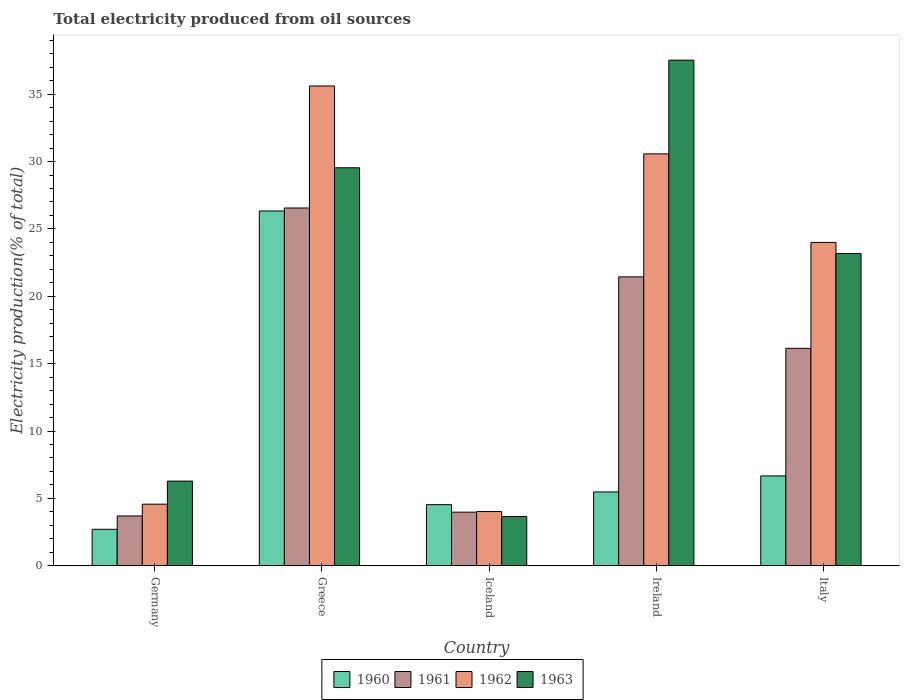How many different coloured bars are there?
Offer a very short reply. 4. How many groups of bars are there?
Keep it short and to the point. 5. How many bars are there on the 5th tick from the left?
Make the answer very short. 4. What is the label of the 1st group of bars from the left?
Ensure brevity in your answer.  Germany. In how many cases, is the number of bars for a given country not equal to the number of legend labels?
Ensure brevity in your answer.  0. What is the total electricity produced in 1961 in Ireland?
Provide a succinct answer. 21.44. Across all countries, what is the maximum total electricity produced in 1963?
Your response must be concise. 37.53. Across all countries, what is the minimum total electricity produced in 1962?
Provide a succinct answer. 4.03. In which country was the total electricity produced in 1963 maximum?
Make the answer very short. Ireland. In which country was the total electricity produced in 1962 minimum?
Your answer should be very brief. Iceland. What is the total total electricity produced in 1960 in the graph?
Your answer should be very brief. 45.73. What is the difference between the total electricity produced in 1960 in Ireland and that in Italy?
Make the answer very short. -1.19. What is the difference between the total electricity produced in 1961 in Greece and the total electricity produced in 1960 in Iceland?
Provide a succinct answer. 22.02. What is the average total electricity produced in 1962 per country?
Ensure brevity in your answer.  19.76. What is the difference between the total electricity produced of/in 1961 and total electricity produced of/in 1962 in Italy?
Provide a succinct answer. -7.86. In how many countries, is the total electricity produced in 1961 greater than 26 %?
Ensure brevity in your answer.  1. What is the ratio of the total electricity produced in 1963 in Iceland to that in Ireland?
Your response must be concise. 0.1. Is the total electricity produced in 1963 in Ireland less than that in Italy?
Your answer should be very brief. No. Is the difference between the total electricity produced in 1961 in Greece and Iceland greater than the difference between the total electricity produced in 1962 in Greece and Iceland?
Provide a succinct answer. No. What is the difference between the highest and the second highest total electricity produced in 1963?
Your answer should be compact. -7.99. What is the difference between the highest and the lowest total electricity produced in 1960?
Make the answer very short. 23.62. What does the 2nd bar from the left in Iceland represents?
Ensure brevity in your answer.  1961. How many countries are there in the graph?
Ensure brevity in your answer.  5. What is the difference between two consecutive major ticks on the Y-axis?
Your answer should be very brief. 5. Are the values on the major ticks of Y-axis written in scientific E-notation?
Your answer should be compact. No. Does the graph contain any zero values?
Your answer should be compact. No. Where does the legend appear in the graph?
Make the answer very short. Bottom center. How many legend labels are there?
Provide a short and direct response. 4. How are the legend labels stacked?
Give a very brief answer. Horizontal. What is the title of the graph?
Give a very brief answer. Total electricity produced from oil sources. What is the label or title of the Y-axis?
Provide a succinct answer. Electricity production(% of total). What is the Electricity production(% of total) of 1960 in Germany?
Your answer should be compact. 2.71. What is the Electricity production(% of total) in 1961 in Germany?
Your answer should be compact. 3.7. What is the Electricity production(% of total) of 1962 in Germany?
Offer a terse response. 4.57. What is the Electricity production(% of total) in 1963 in Germany?
Ensure brevity in your answer.  6.28. What is the Electricity production(% of total) in 1960 in Greece?
Offer a very short reply. 26.33. What is the Electricity production(% of total) in 1961 in Greece?
Offer a terse response. 26.55. What is the Electricity production(% of total) in 1962 in Greece?
Your response must be concise. 35.61. What is the Electricity production(% of total) in 1963 in Greece?
Make the answer very short. 29.54. What is the Electricity production(% of total) of 1960 in Iceland?
Provide a succinct answer. 4.54. What is the Electricity production(% of total) in 1961 in Iceland?
Give a very brief answer. 3.98. What is the Electricity production(% of total) in 1962 in Iceland?
Offer a very short reply. 4.03. What is the Electricity production(% of total) in 1963 in Iceland?
Ensure brevity in your answer.  3.66. What is the Electricity production(% of total) in 1960 in Ireland?
Make the answer very short. 5.48. What is the Electricity production(% of total) of 1961 in Ireland?
Offer a terse response. 21.44. What is the Electricity production(% of total) in 1962 in Ireland?
Your answer should be very brief. 30.57. What is the Electricity production(% of total) in 1963 in Ireland?
Ensure brevity in your answer.  37.53. What is the Electricity production(% of total) of 1960 in Italy?
Your response must be concise. 6.67. What is the Electricity production(% of total) in 1961 in Italy?
Your answer should be very brief. 16.14. What is the Electricity production(% of total) of 1962 in Italy?
Provide a short and direct response. 24. What is the Electricity production(% of total) of 1963 in Italy?
Your response must be concise. 23.17. Across all countries, what is the maximum Electricity production(% of total) of 1960?
Offer a terse response. 26.33. Across all countries, what is the maximum Electricity production(% of total) of 1961?
Your response must be concise. 26.55. Across all countries, what is the maximum Electricity production(% of total) in 1962?
Provide a short and direct response. 35.61. Across all countries, what is the maximum Electricity production(% of total) in 1963?
Provide a short and direct response. 37.53. Across all countries, what is the minimum Electricity production(% of total) in 1960?
Offer a terse response. 2.71. Across all countries, what is the minimum Electricity production(% of total) of 1961?
Make the answer very short. 3.7. Across all countries, what is the minimum Electricity production(% of total) in 1962?
Keep it short and to the point. 4.03. Across all countries, what is the minimum Electricity production(% of total) in 1963?
Keep it short and to the point. 3.66. What is the total Electricity production(% of total) in 1960 in the graph?
Keep it short and to the point. 45.73. What is the total Electricity production(% of total) in 1961 in the graph?
Give a very brief answer. 71.81. What is the total Electricity production(% of total) of 1962 in the graph?
Give a very brief answer. 98.78. What is the total Electricity production(% of total) in 1963 in the graph?
Provide a short and direct response. 100.18. What is the difference between the Electricity production(% of total) of 1960 in Germany and that in Greece?
Your response must be concise. -23.62. What is the difference between the Electricity production(% of total) of 1961 in Germany and that in Greece?
Your answer should be compact. -22.86. What is the difference between the Electricity production(% of total) in 1962 in Germany and that in Greece?
Your response must be concise. -31.04. What is the difference between the Electricity production(% of total) in 1963 in Germany and that in Greece?
Offer a terse response. -23.26. What is the difference between the Electricity production(% of total) of 1960 in Germany and that in Iceland?
Make the answer very short. -1.83. What is the difference between the Electricity production(% of total) of 1961 in Germany and that in Iceland?
Offer a very short reply. -0.28. What is the difference between the Electricity production(% of total) of 1962 in Germany and that in Iceland?
Offer a terse response. 0.55. What is the difference between the Electricity production(% of total) of 1963 in Germany and that in Iceland?
Provide a succinct answer. 2.63. What is the difference between the Electricity production(% of total) of 1960 in Germany and that in Ireland?
Provide a succinct answer. -2.77. What is the difference between the Electricity production(% of total) of 1961 in Germany and that in Ireland?
Give a very brief answer. -17.75. What is the difference between the Electricity production(% of total) of 1962 in Germany and that in Ireland?
Your answer should be compact. -26. What is the difference between the Electricity production(% of total) in 1963 in Germany and that in Ireland?
Offer a terse response. -31.24. What is the difference between the Electricity production(% of total) of 1960 in Germany and that in Italy?
Provide a succinct answer. -3.96. What is the difference between the Electricity production(% of total) of 1961 in Germany and that in Italy?
Your answer should be compact. -12.44. What is the difference between the Electricity production(% of total) of 1962 in Germany and that in Italy?
Your response must be concise. -19.43. What is the difference between the Electricity production(% of total) in 1963 in Germany and that in Italy?
Provide a succinct answer. -16.89. What is the difference between the Electricity production(% of total) of 1960 in Greece and that in Iceland?
Provide a short and direct response. 21.79. What is the difference between the Electricity production(% of total) in 1961 in Greece and that in Iceland?
Give a very brief answer. 22.57. What is the difference between the Electricity production(% of total) in 1962 in Greece and that in Iceland?
Provide a short and direct response. 31.58. What is the difference between the Electricity production(% of total) in 1963 in Greece and that in Iceland?
Give a very brief answer. 25.88. What is the difference between the Electricity production(% of total) of 1960 in Greece and that in Ireland?
Provide a succinct answer. 20.85. What is the difference between the Electricity production(% of total) of 1961 in Greece and that in Ireland?
Offer a very short reply. 5.11. What is the difference between the Electricity production(% of total) in 1962 in Greece and that in Ireland?
Your answer should be compact. 5.04. What is the difference between the Electricity production(% of total) in 1963 in Greece and that in Ireland?
Make the answer very short. -7.99. What is the difference between the Electricity production(% of total) in 1960 in Greece and that in Italy?
Your answer should be compact. 19.66. What is the difference between the Electricity production(% of total) of 1961 in Greece and that in Italy?
Make the answer very short. 10.42. What is the difference between the Electricity production(% of total) in 1962 in Greece and that in Italy?
Offer a very short reply. 11.61. What is the difference between the Electricity production(% of total) of 1963 in Greece and that in Italy?
Your answer should be very brief. 6.37. What is the difference between the Electricity production(% of total) in 1960 in Iceland and that in Ireland?
Give a very brief answer. -0.94. What is the difference between the Electricity production(% of total) of 1961 in Iceland and that in Ireland?
Make the answer very short. -17.46. What is the difference between the Electricity production(% of total) in 1962 in Iceland and that in Ireland?
Provide a short and direct response. -26.55. What is the difference between the Electricity production(% of total) in 1963 in Iceland and that in Ireland?
Provide a short and direct response. -33.87. What is the difference between the Electricity production(% of total) in 1960 in Iceland and that in Italy?
Make the answer very short. -2.13. What is the difference between the Electricity production(% of total) in 1961 in Iceland and that in Italy?
Your response must be concise. -12.16. What is the difference between the Electricity production(% of total) of 1962 in Iceland and that in Italy?
Your answer should be compact. -19.97. What is the difference between the Electricity production(% of total) of 1963 in Iceland and that in Italy?
Provide a succinct answer. -19.52. What is the difference between the Electricity production(% of total) in 1960 in Ireland and that in Italy?
Keep it short and to the point. -1.19. What is the difference between the Electricity production(% of total) of 1961 in Ireland and that in Italy?
Offer a terse response. 5.3. What is the difference between the Electricity production(% of total) of 1962 in Ireland and that in Italy?
Your answer should be compact. 6.57. What is the difference between the Electricity production(% of total) in 1963 in Ireland and that in Italy?
Offer a terse response. 14.35. What is the difference between the Electricity production(% of total) of 1960 in Germany and the Electricity production(% of total) of 1961 in Greece?
Give a very brief answer. -23.85. What is the difference between the Electricity production(% of total) in 1960 in Germany and the Electricity production(% of total) in 1962 in Greece?
Give a very brief answer. -32.9. What is the difference between the Electricity production(% of total) of 1960 in Germany and the Electricity production(% of total) of 1963 in Greece?
Your answer should be compact. -26.83. What is the difference between the Electricity production(% of total) of 1961 in Germany and the Electricity production(% of total) of 1962 in Greece?
Offer a very short reply. -31.91. What is the difference between the Electricity production(% of total) of 1961 in Germany and the Electricity production(% of total) of 1963 in Greece?
Ensure brevity in your answer.  -25.84. What is the difference between the Electricity production(% of total) of 1962 in Germany and the Electricity production(% of total) of 1963 in Greece?
Make the answer very short. -24.97. What is the difference between the Electricity production(% of total) of 1960 in Germany and the Electricity production(% of total) of 1961 in Iceland?
Ensure brevity in your answer.  -1.27. What is the difference between the Electricity production(% of total) in 1960 in Germany and the Electricity production(% of total) in 1962 in Iceland?
Make the answer very short. -1.32. What is the difference between the Electricity production(% of total) in 1960 in Germany and the Electricity production(% of total) in 1963 in Iceland?
Your answer should be compact. -0.95. What is the difference between the Electricity production(% of total) in 1961 in Germany and the Electricity production(% of total) in 1962 in Iceland?
Provide a succinct answer. -0.33. What is the difference between the Electricity production(% of total) in 1961 in Germany and the Electricity production(% of total) in 1963 in Iceland?
Your answer should be compact. 0.04. What is the difference between the Electricity production(% of total) of 1962 in Germany and the Electricity production(% of total) of 1963 in Iceland?
Offer a very short reply. 0.91. What is the difference between the Electricity production(% of total) in 1960 in Germany and the Electricity production(% of total) in 1961 in Ireland?
Offer a very short reply. -18.73. What is the difference between the Electricity production(% of total) in 1960 in Germany and the Electricity production(% of total) in 1962 in Ireland?
Your answer should be very brief. -27.86. What is the difference between the Electricity production(% of total) of 1960 in Germany and the Electricity production(% of total) of 1963 in Ireland?
Your answer should be very brief. -34.82. What is the difference between the Electricity production(% of total) in 1961 in Germany and the Electricity production(% of total) in 1962 in Ireland?
Keep it short and to the point. -26.87. What is the difference between the Electricity production(% of total) in 1961 in Germany and the Electricity production(% of total) in 1963 in Ireland?
Provide a succinct answer. -33.83. What is the difference between the Electricity production(% of total) of 1962 in Germany and the Electricity production(% of total) of 1963 in Ireland?
Offer a very short reply. -32.95. What is the difference between the Electricity production(% of total) of 1960 in Germany and the Electricity production(% of total) of 1961 in Italy?
Ensure brevity in your answer.  -13.43. What is the difference between the Electricity production(% of total) in 1960 in Germany and the Electricity production(% of total) in 1962 in Italy?
Keep it short and to the point. -21.29. What is the difference between the Electricity production(% of total) in 1960 in Germany and the Electricity production(% of total) in 1963 in Italy?
Offer a very short reply. -20.47. What is the difference between the Electricity production(% of total) in 1961 in Germany and the Electricity production(% of total) in 1962 in Italy?
Ensure brevity in your answer.  -20.3. What is the difference between the Electricity production(% of total) in 1961 in Germany and the Electricity production(% of total) in 1963 in Italy?
Make the answer very short. -19.48. What is the difference between the Electricity production(% of total) of 1962 in Germany and the Electricity production(% of total) of 1963 in Italy?
Your answer should be compact. -18.6. What is the difference between the Electricity production(% of total) of 1960 in Greece and the Electricity production(% of total) of 1961 in Iceland?
Ensure brevity in your answer.  22.35. What is the difference between the Electricity production(% of total) of 1960 in Greece and the Electricity production(% of total) of 1962 in Iceland?
Your answer should be compact. 22.31. What is the difference between the Electricity production(% of total) of 1960 in Greece and the Electricity production(% of total) of 1963 in Iceland?
Provide a succinct answer. 22.67. What is the difference between the Electricity production(% of total) of 1961 in Greece and the Electricity production(% of total) of 1962 in Iceland?
Offer a terse response. 22.53. What is the difference between the Electricity production(% of total) of 1961 in Greece and the Electricity production(% of total) of 1963 in Iceland?
Provide a short and direct response. 22.9. What is the difference between the Electricity production(% of total) in 1962 in Greece and the Electricity production(% of total) in 1963 in Iceland?
Make the answer very short. 31.95. What is the difference between the Electricity production(% of total) in 1960 in Greece and the Electricity production(% of total) in 1961 in Ireland?
Provide a short and direct response. 4.89. What is the difference between the Electricity production(% of total) in 1960 in Greece and the Electricity production(% of total) in 1962 in Ireland?
Keep it short and to the point. -4.24. What is the difference between the Electricity production(% of total) of 1960 in Greece and the Electricity production(% of total) of 1963 in Ireland?
Your answer should be compact. -11.19. What is the difference between the Electricity production(% of total) of 1961 in Greece and the Electricity production(% of total) of 1962 in Ireland?
Make the answer very short. -4.02. What is the difference between the Electricity production(% of total) of 1961 in Greece and the Electricity production(% of total) of 1963 in Ireland?
Your answer should be very brief. -10.97. What is the difference between the Electricity production(% of total) of 1962 in Greece and the Electricity production(% of total) of 1963 in Ireland?
Provide a succinct answer. -1.92. What is the difference between the Electricity production(% of total) in 1960 in Greece and the Electricity production(% of total) in 1961 in Italy?
Your response must be concise. 10.19. What is the difference between the Electricity production(% of total) of 1960 in Greece and the Electricity production(% of total) of 1962 in Italy?
Keep it short and to the point. 2.33. What is the difference between the Electricity production(% of total) in 1960 in Greece and the Electricity production(% of total) in 1963 in Italy?
Provide a succinct answer. 3.16. What is the difference between the Electricity production(% of total) of 1961 in Greece and the Electricity production(% of total) of 1962 in Italy?
Provide a succinct answer. 2.55. What is the difference between the Electricity production(% of total) in 1961 in Greece and the Electricity production(% of total) in 1963 in Italy?
Your answer should be compact. 3.38. What is the difference between the Electricity production(% of total) of 1962 in Greece and the Electricity production(% of total) of 1963 in Italy?
Give a very brief answer. 12.44. What is the difference between the Electricity production(% of total) in 1960 in Iceland and the Electricity production(% of total) in 1961 in Ireland?
Offer a very short reply. -16.91. What is the difference between the Electricity production(% of total) of 1960 in Iceland and the Electricity production(% of total) of 1962 in Ireland?
Your answer should be very brief. -26.03. What is the difference between the Electricity production(% of total) in 1960 in Iceland and the Electricity production(% of total) in 1963 in Ireland?
Your answer should be very brief. -32.99. What is the difference between the Electricity production(% of total) in 1961 in Iceland and the Electricity production(% of total) in 1962 in Ireland?
Keep it short and to the point. -26.59. What is the difference between the Electricity production(% of total) of 1961 in Iceland and the Electricity production(% of total) of 1963 in Ireland?
Provide a succinct answer. -33.55. What is the difference between the Electricity production(% of total) in 1962 in Iceland and the Electricity production(% of total) in 1963 in Ireland?
Keep it short and to the point. -33.5. What is the difference between the Electricity production(% of total) of 1960 in Iceland and the Electricity production(% of total) of 1961 in Italy?
Provide a short and direct response. -11.6. What is the difference between the Electricity production(% of total) in 1960 in Iceland and the Electricity production(% of total) in 1962 in Italy?
Make the answer very short. -19.46. What is the difference between the Electricity production(% of total) of 1960 in Iceland and the Electricity production(% of total) of 1963 in Italy?
Make the answer very short. -18.64. What is the difference between the Electricity production(% of total) of 1961 in Iceland and the Electricity production(% of total) of 1962 in Italy?
Your answer should be compact. -20.02. What is the difference between the Electricity production(% of total) of 1961 in Iceland and the Electricity production(% of total) of 1963 in Italy?
Your answer should be very brief. -19.19. What is the difference between the Electricity production(% of total) of 1962 in Iceland and the Electricity production(% of total) of 1963 in Italy?
Provide a succinct answer. -19.15. What is the difference between the Electricity production(% of total) of 1960 in Ireland and the Electricity production(% of total) of 1961 in Italy?
Make the answer very short. -10.66. What is the difference between the Electricity production(% of total) of 1960 in Ireland and the Electricity production(% of total) of 1962 in Italy?
Give a very brief answer. -18.52. What is the difference between the Electricity production(% of total) of 1960 in Ireland and the Electricity production(% of total) of 1963 in Italy?
Your response must be concise. -17.69. What is the difference between the Electricity production(% of total) of 1961 in Ireland and the Electricity production(% of total) of 1962 in Italy?
Your answer should be compact. -2.56. What is the difference between the Electricity production(% of total) of 1961 in Ireland and the Electricity production(% of total) of 1963 in Italy?
Keep it short and to the point. -1.73. What is the difference between the Electricity production(% of total) of 1962 in Ireland and the Electricity production(% of total) of 1963 in Italy?
Make the answer very short. 7.4. What is the average Electricity production(% of total) in 1960 per country?
Provide a succinct answer. 9.15. What is the average Electricity production(% of total) in 1961 per country?
Provide a short and direct response. 14.36. What is the average Electricity production(% of total) in 1962 per country?
Provide a succinct answer. 19.76. What is the average Electricity production(% of total) of 1963 per country?
Your answer should be compact. 20.04. What is the difference between the Electricity production(% of total) of 1960 and Electricity production(% of total) of 1961 in Germany?
Offer a terse response. -0.99. What is the difference between the Electricity production(% of total) of 1960 and Electricity production(% of total) of 1962 in Germany?
Keep it short and to the point. -1.86. What is the difference between the Electricity production(% of total) in 1960 and Electricity production(% of total) in 1963 in Germany?
Your answer should be very brief. -3.58. What is the difference between the Electricity production(% of total) in 1961 and Electricity production(% of total) in 1962 in Germany?
Your answer should be very brief. -0.87. What is the difference between the Electricity production(% of total) of 1961 and Electricity production(% of total) of 1963 in Germany?
Your answer should be compact. -2.59. What is the difference between the Electricity production(% of total) in 1962 and Electricity production(% of total) in 1963 in Germany?
Your answer should be very brief. -1.71. What is the difference between the Electricity production(% of total) in 1960 and Electricity production(% of total) in 1961 in Greece?
Give a very brief answer. -0.22. What is the difference between the Electricity production(% of total) of 1960 and Electricity production(% of total) of 1962 in Greece?
Offer a very short reply. -9.28. What is the difference between the Electricity production(% of total) in 1960 and Electricity production(% of total) in 1963 in Greece?
Keep it short and to the point. -3.21. What is the difference between the Electricity production(% of total) of 1961 and Electricity production(% of total) of 1962 in Greece?
Ensure brevity in your answer.  -9.06. What is the difference between the Electricity production(% of total) of 1961 and Electricity production(% of total) of 1963 in Greece?
Provide a short and direct response. -2.99. What is the difference between the Electricity production(% of total) in 1962 and Electricity production(% of total) in 1963 in Greece?
Offer a very short reply. 6.07. What is the difference between the Electricity production(% of total) in 1960 and Electricity production(% of total) in 1961 in Iceland?
Offer a terse response. 0.56. What is the difference between the Electricity production(% of total) of 1960 and Electricity production(% of total) of 1962 in Iceland?
Give a very brief answer. 0.51. What is the difference between the Electricity production(% of total) in 1960 and Electricity production(% of total) in 1963 in Iceland?
Your response must be concise. 0.88. What is the difference between the Electricity production(% of total) of 1961 and Electricity production(% of total) of 1962 in Iceland?
Provide a short and direct response. -0.05. What is the difference between the Electricity production(% of total) of 1961 and Electricity production(% of total) of 1963 in Iceland?
Ensure brevity in your answer.  0.32. What is the difference between the Electricity production(% of total) in 1962 and Electricity production(% of total) in 1963 in Iceland?
Ensure brevity in your answer.  0.37. What is the difference between the Electricity production(% of total) in 1960 and Electricity production(% of total) in 1961 in Ireland?
Provide a short and direct response. -15.96. What is the difference between the Electricity production(% of total) of 1960 and Electricity production(% of total) of 1962 in Ireland?
Keep it short and to the point. -25.09. What is the difference between the Electricity production(% of total) of 1960 and Electricity production(% of total) of 1963 in Ireland?
Make the answer very short. -32.04. What is the difference between the Electricity production(% of total) in 1961 and Electricity production(% of total) in 1962 in Ireland?
Offer a very short reply. -9.13. What is the difference between the Electricity production(% of total) in 1961 and Electricity production(% of total) in 1963 in Ireland?
Keep it short and to the point. -16.08. What is the difference between the Electricity production(% of total) of 1962 and Electricity production(% of total) of 1963 in Ireland?
Keep it short and to the point. -6.95. What is the difference between the Electricity production(% of total) in 1960 and Electricity production(% of total) in 1961 in Italy?
Your answer should be very brief. -9.47. What is the difference between the Electricity production(% of total) of 1960 and Electricity production(% of total) of 1962 in Italy?
Give a very brief answer. -17.33. What is the difference between the Electricity production(% of total) in 1960 and Electricity production(% of total) in 1963 in Italy?
Keep it short and to the point. -16.5. What is the difference between the Electricity production(% of total) of 1961 and Electricity production(% of total) of 1962 in Italy?
Offer a very short reply. -7.86. What is the difference between the Electricity production(% of total) of 1961 and Electricity production(% of total) of 1963 in Italy?
Provide a succinct answer. -7.04. What is the difference between the Electricity production(% of total) in 1962 and Electricity production(% of total) in 1963 in Italy?
Keep it short and to the point. 0.83. What is the ratio of the Electricity production(% of total) of 1960 in Germany to that in Greece?
Offer a very short reply. 0.1. What is the ratio of the Electricity production(% of total) of 1961 in Germany to that in Greece?
Keep it short and to the point. 0.14. What is the ratio of the Electricity production(% of total) of 1962 in Germany to that in Greece?
Offer a terse response. 0.13. What is the ratio of the Electricity production(% of total) in 1963 in Germany to that in Greece?
Offer a terse response. 0.21. What is the ratio of the Electricity production(% of total) in 1960 in Germany to that in Iceland?
Keep it short and to the point. 0.6. What is the ratio of the Electricity production(% of total) in 1961 in Germany to that in Iceland?
Keep it short and to the point. 0.93. What is the ratio of the Electricity production(% of total) of 1962 in Germany to that in Iceland?
Make the answer very short. 1.14. What is the ratio of the Electricity production(% of total) of 1963 in Germany to that in Iceland?
Ensure brevity in your answer.  1.72. What is the ratio of the Electricity production(% of total) in 1960 in Germany to that in Ireland?
Your answer should be very brief. 0.49. What is the ratio of the Electricity production(% of total) of 1961 in Germany to that in Ireland?
Your answer should be compact. 0.17. What is the ratio of the Electricity production(% of total) of 1962 in Germany to that in Ireland?
Your response must be concise. 0.15. What is the ratio of the Electricity production(% of total) of 1963 in Germany to that in Ireland?
Your response must be concise. 0.17. What is the ratio of the Electricity production(% of total) in 1960 in Germany to that in Italy?
Provide a succinct answer. 0.41. What is the ratio of the Electricity production(% of total) in 1961 in Germany to that in Italy?
Your answer should be compact. 0.23. What is the ratio of the Electricity production(% of total) in 1962 in Germany to that in Italy?
Your response must be concise. 0.19. What is the ratio of the Electricity production(% of total) of 1963 in Germany to that in Italy?
Your response must be concise. 0.27. What is the ratio of the Electricity production(% of total) of 1960 in Greece to that in Iceland?
Ensure brevity in your answer.  5.8. What is the ratio of the Electricity production(% of total) of 1961 in Greece to that in Iceland?
Provide a succinct answer. 6.67. What is the ratio of the Electricity production(% of total) of 1962 in Greece to that in Iceland?
Your answer should be compact. 8.85. What is the ratio of the Electricity production(% of total) in 1963 in Greece to that in Iceland?
Make the answer very short. 8.07. What is the ratio of the Electricity production(% of total) of 1960 in Greece to that in Ireland?
Offer a very short reply. 4.8. What is the ratio of the Electricity production(% of total) of 1961 in Greece to that in Ireland?
Provide a short and direct response. 1.24. What is the ratio of the Electricity production(% of total) in 1962 in Greece to that in Ireland?
Your response must be concise. 1.16. What is the ratio of the Electricity production(% of total) in 1963 in Greece to that in Ireland?
Make the answer very short. 0.79. What is the ratio of the Electricity production(% of total) in 1960 in Greece to that in Italy?
Your answer should be compact. 3.95. What is the ratio of the Electricity production(% of total) of 1961 in Greece to that in Italy?
Keep it short and to the point. 1.65. What is the ratio of the Electricity production(% of total) of 1962 in Greece to that in Italy?
Your answer should be compact. 1.48. What is the ratio of the Electricity production(% of total) in 1963 in Greece to that in Italy?
Provide a succinct answer. 1.27. What is the ratio of the Electricity production(% of total) in 1960 in Iceland to that in Ireland?
Keep it short and to the point. 0.83. What is the ratio of the Electricity production(% of total) of 1961 in Iceland to that in Ireland?
Offer a terse response. 0.19. What is the ratio of the Electricity production(% of total) of 1962 in Iceland to that in Ireland?
Provide a succinct answer. 0.13. What is the ratio of the Electricity production(% of total) of 1963 in Iceland to that in Ireland?
Make the answer very short. 0.1. What is the ratio of the Electricity production(% of total) of 1960 in Iceland to that in Italy?
Keep it short and to the point. 0.68. What is the ratio of the Electricity production(% of total) of 1961 in Iceland to that in Italy?
Offer a very short reply. 0.25. What is the ratio of the Electricity production(% of total) in 1962 in Iceland to that in Italy?
Provide a short and direct response. 0.17. What is the ratio of the Electricity production(% of total) of 1963 in Iceland to that in Italy?
Your answer should be very brief. 0.16. What is the ratio of the Electricity production(% of total) of 1960 in Ireland to that in Italy?
Make the answer very short. 0.82. What is the ratio of the Electricity production(% of total) of 1961 in Ireland to that in Italy?
Provide a short and direct response. 1.33. What is the ratio of the Electricity production(% of total) in 1962 in Ireland to that in Italy?
Keep it short and to the point. 1.27. What is the ratio of the Electricity production(% of total) of 1963 in Ireland to that in Italy?
Your response must be concise. 1.62. What is the difference between the highest and the second highest Electricity production(% of total) of 1960?
Ensure brevity in your answer.  19.66. What is the difference between the highest and the second highest Electricity production(% of total) in 1961?
Make the answer very short. 5.11. What is the difference between the highest and the second highest Electricity production(% of total) of 1962?
Make the answer very short. 5.04. What is the difference between the highest and the second highest Electricity production(% of total) in 1963?
Your answer should be very brief. 7.99. What is the difference between the highest and the lowest Electricity production(% of total) of 1960?
Offer a very short reply. 23.62. What is the difference between the highest and the lowest Electricity production(% of total) of 1961?
Your response must be concise. 22.86. What is the difference between the highest and the lowest Electricity production(% of total) of 1962?
Your answer should be compact. 31.58. What is the difference between the highest and the lowest Electricity production(% of total) of 1963?
Give a very brief answer. 33.87. 